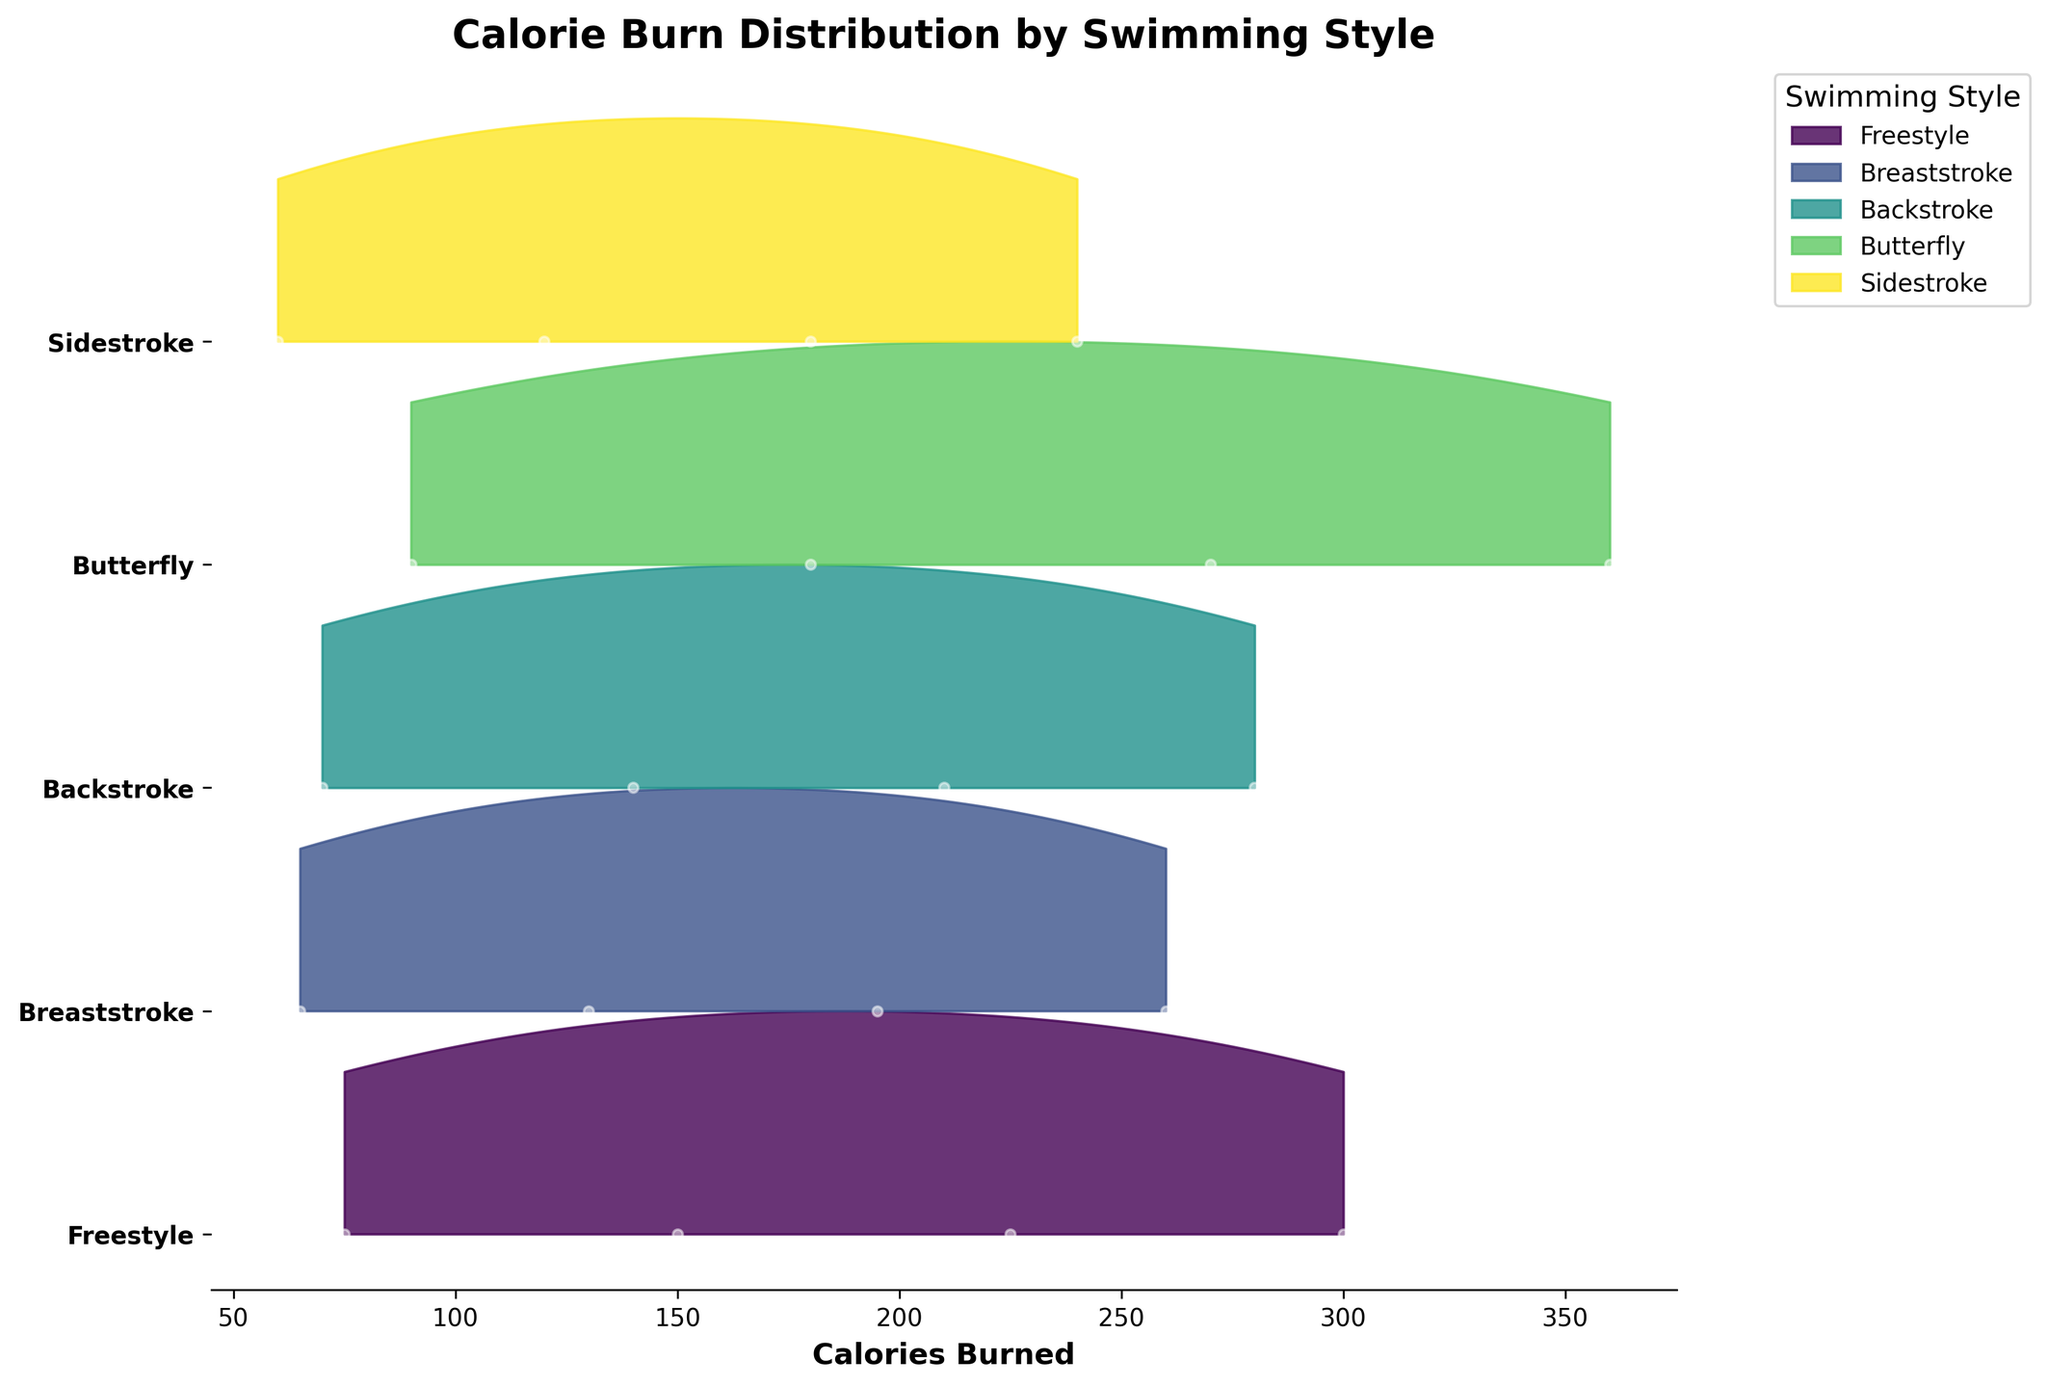What is the title of the figure? The title is located at the top of the figure. It provides a brief description of the content being visualized.
Answer: Calorie Burn Distribution by Swimming Style What does the x-axis represent in the figure? The x-axis is labeled 'Calories Burned.' It shows the number of calories burned for different swimming styles and durations.
Answer: Calories Burned How many swimming styles are represented in the figure? The figure includes a legend that lists all the represented swimming styles. By counting these entries, we can determine the number of swimming styles.
Answer: 5 Which swimming style has the highest maximum calorie burn? To determine this, we look at the maximum values for each swimming style in the ridgeline plot. The highest maximum value indicates the style.
Answer: Butterfly For Freestyle, what is the range of calories burned shown? The range can be determined by checking the minimum and maximum values on the x-axis within the Freestyle section of the plot. This covers the entire span of calories burned for that style.
Answer: 75 to 300 Which swimming style has the lowest minimum calorie burn? By examining the minimum values on the x-axis for each swimming style, we can identify the style with the lowest starting number of calories burned.
Answer: Sidestroke How does the calorie burn distribution differ between Freestyle and Backstroke? To compare, we examine the shape and spread of the ridgeline distributions for both Freestyle and Backstroke. Freestyle has a wider range of calories burned than Backstroke and reaches higher maximum values.
Answer: Freestyle has a wider range and higher max values than Backstroke Which style has the steepest increase in calorie burn over duration? By observing the slope of the data points on the ridgeline plot for each style, we can identify the style with the most rapid increase.
Answer: Butterfly Is there a noticeable difference in the distributions between any two styles? Comparison of the ridgeline shapes will reveal whether any two styles have markedly different calorie burn distributions. Butterfly’s distribution is both wider and has a higher maximum value compared to others, indicating a noticeable difference.
Answer: Yes, Butterfly compared to others How are the calories burned data points distributed for Sidestroke? Examining the individual markers (o) and the ridgeline for Sidestroke will show the distribution of calorie burn values. Sidestroke has lower calorie burn values close together compared to other styles.
Answer: Lower values close together 